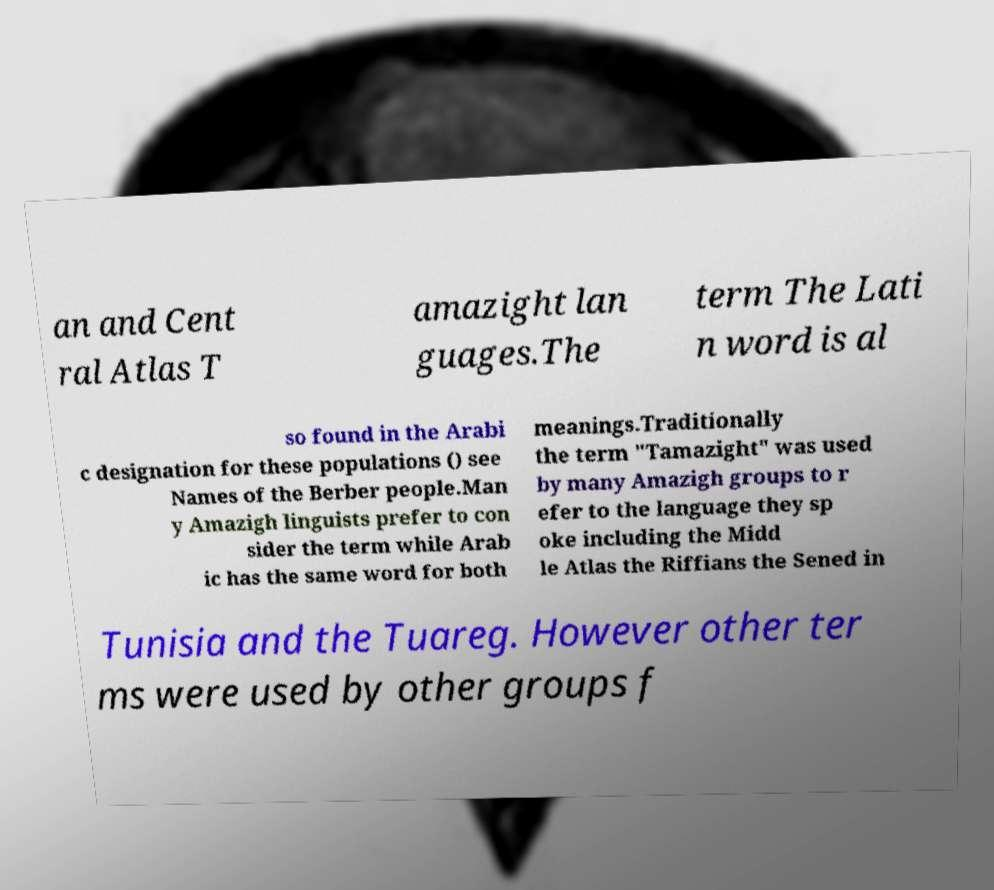For documentation purposes, I need the text within this image transcribed. Could you provide that? an and Cent ral Atlas T amazight lan guages.The term The Lati n word is al so found in the Arabi c designation for these populations () see Names of the Berber people.Man y Amazigh linguists prefer to con sider the term while Arab ic has the same word for both meanings.Traditionally the term "Tamazight" was used by many Amazigh groups to r efer to the language they sp oke including the Midd le Atlas the Riffians the Sened in Tunisia and the Tuareg. However other ter ms were used by other groups f 